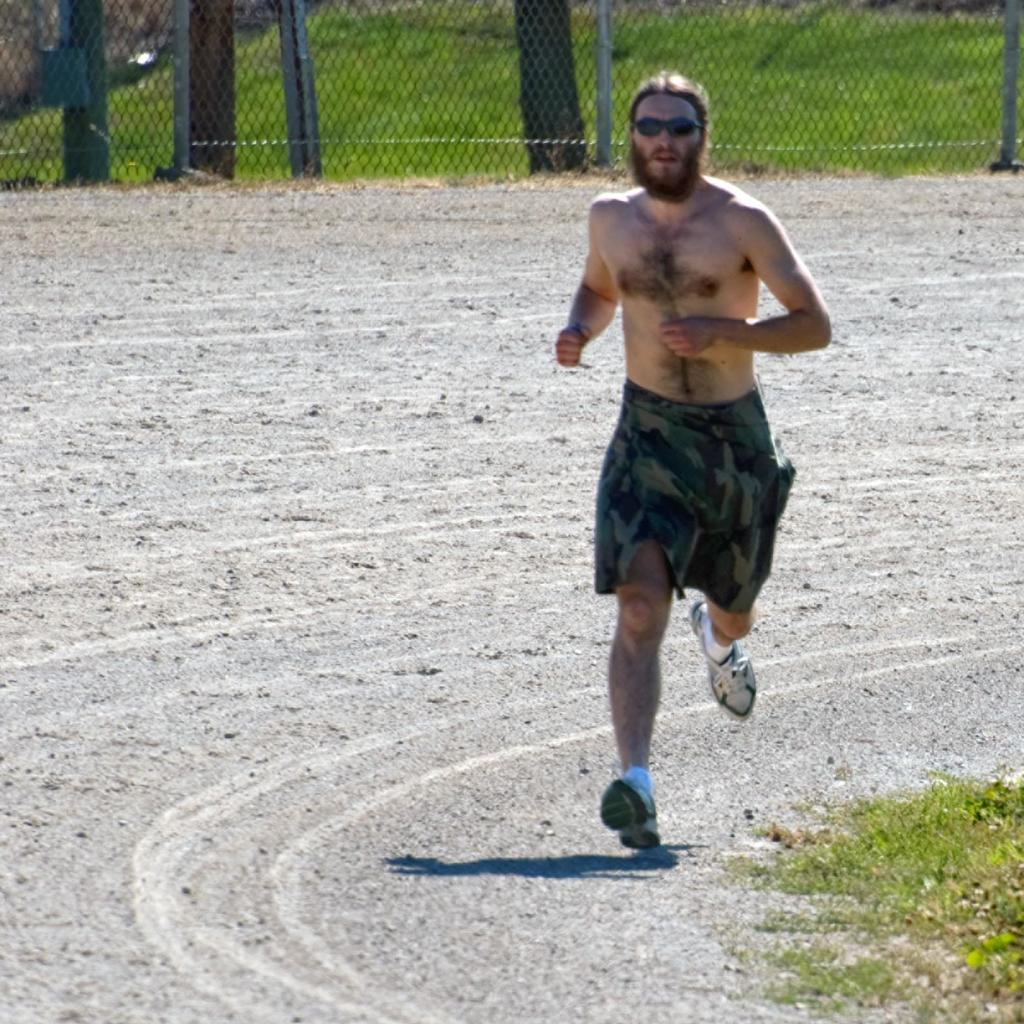What is the person in the image doing? The person is running in the image. Where is the person running? The person is running on a road. What type of vegetation can be seen on the path? Some grass is visible on the path. What can be seen in the background of the image? There is fencing in the background of the image. What noise can be heard coming from the visitor in the image? There is no visitor present in the image, so no noise can be heard from them. 